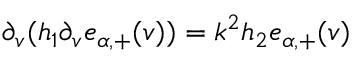Convert formula to latex. <formula><loc_0><loc_0><loc_500><loc_500>\begin{array} { r } { \partial _ { v } ( h _ { 1 } \partial _ { v } \mathfrak { e } _ { \alpha , + } ( v ) ) = k ^ { 2 } h _ { 2 } \mathfrak { e } _ { \alpha , + } ( v ) } \end{array}</formula> 